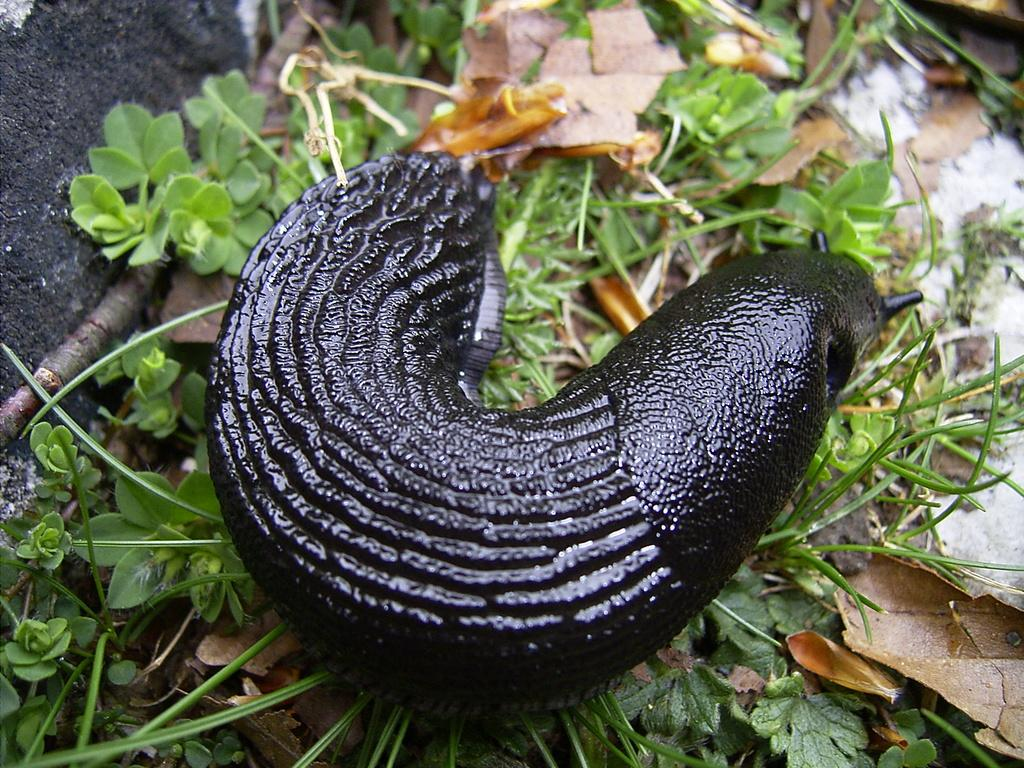What is the main subject in the center of the image? There is a snail in the center of the image. What can be seen in the background of the image? There are plants and dry leaves in the background of the image. What object is located on the left side of the image? There is a stone on the left side of the image. How does the snail burst through the stone in the image? The snail does not burst through the stone in the image; it is simply resting on the stone. 